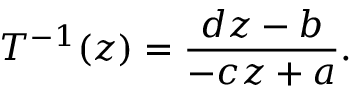<formula> <loc_0><loc_0><loc_500><loc_500>T ^ { - 1 } ( z ) = \frac { d z - b } { - c z + a } .</formula> 